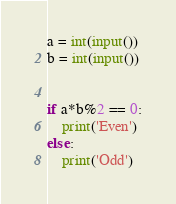Convert code to text. <code><loc_0><loc_0><loc_500><loc_500><_Python_>a = int(input())
b = int(input())


if a*b%2 == 0:
	print('Even')
else:
	print('Odd')</code> 